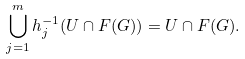Convert formula to latex. <formula><loc_0><loc_0><loc_500><loc_500>\bigcup _ { j = 1 } ^ { m } h _ { j } ^ { - 1 } ( U \cap F ( G ) ) = U \cap F ( G ) .</formula> 